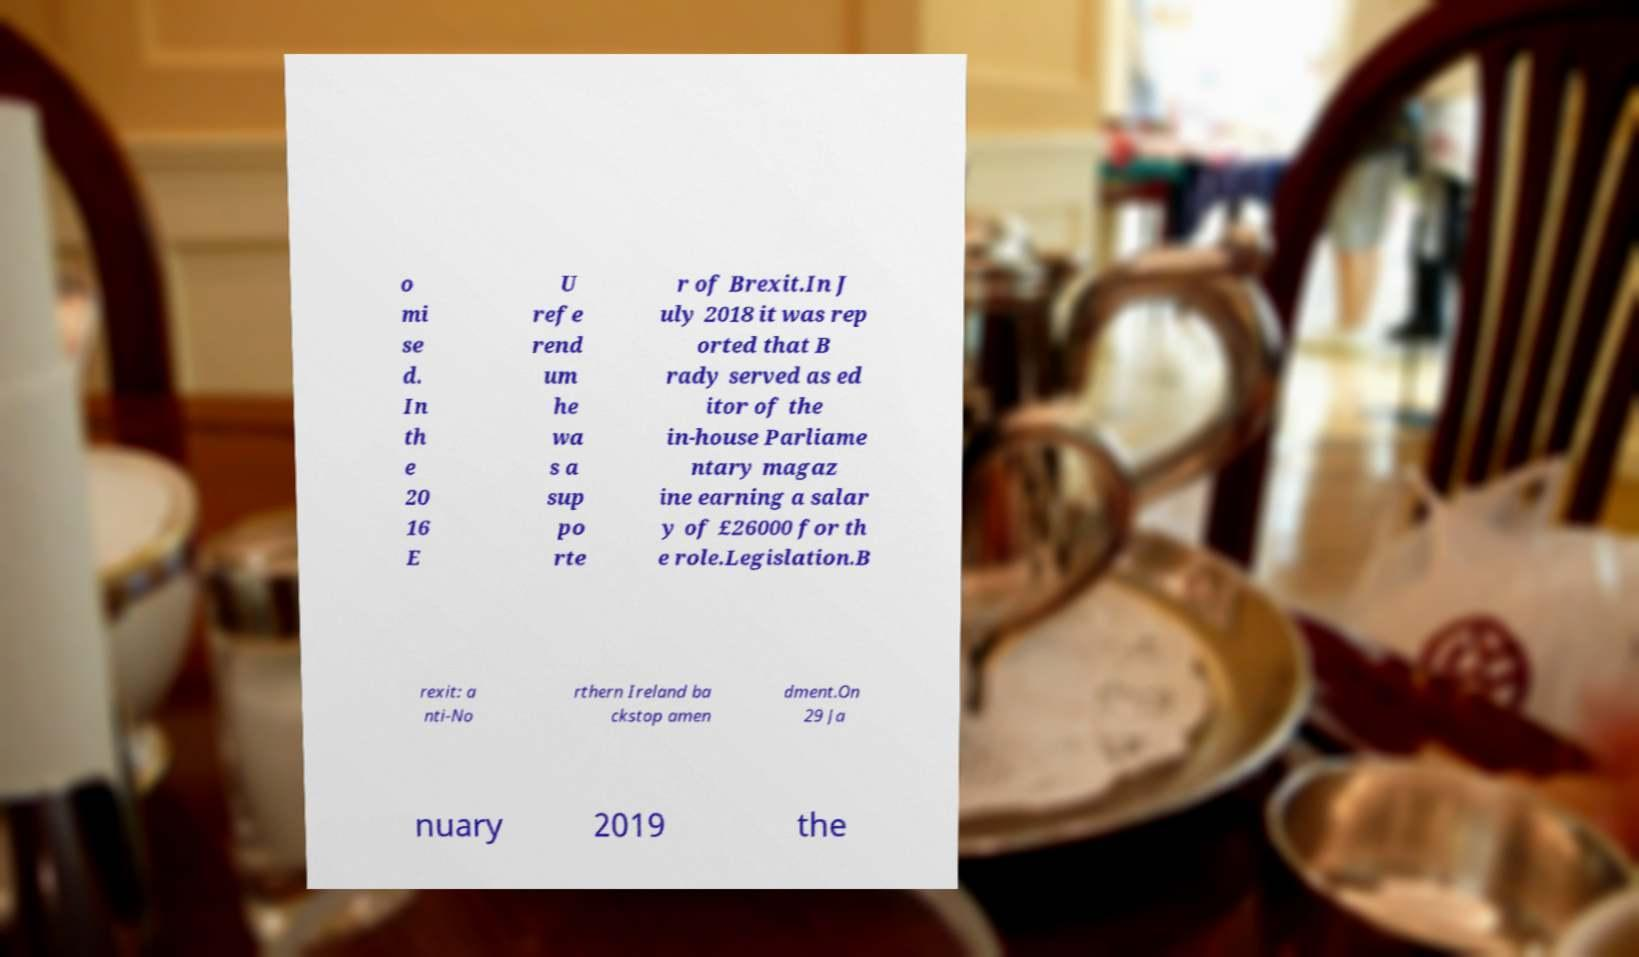Could you assist in decoding the text presented in this image and type it out clearly? o mi se d. In th e 20 16 E U refe rend um he wa s a sup po rte r of Brexit.In J uly 2018 it was rep orted that B rady served as ed itor of the in-house Parliame ntary magaz ine earning a salar y of £26000 for th e role.Legislation.B rexit: a nti-No rthern Ireland ba ckstop amen dment.On 29 Ja nuary 2019 the 